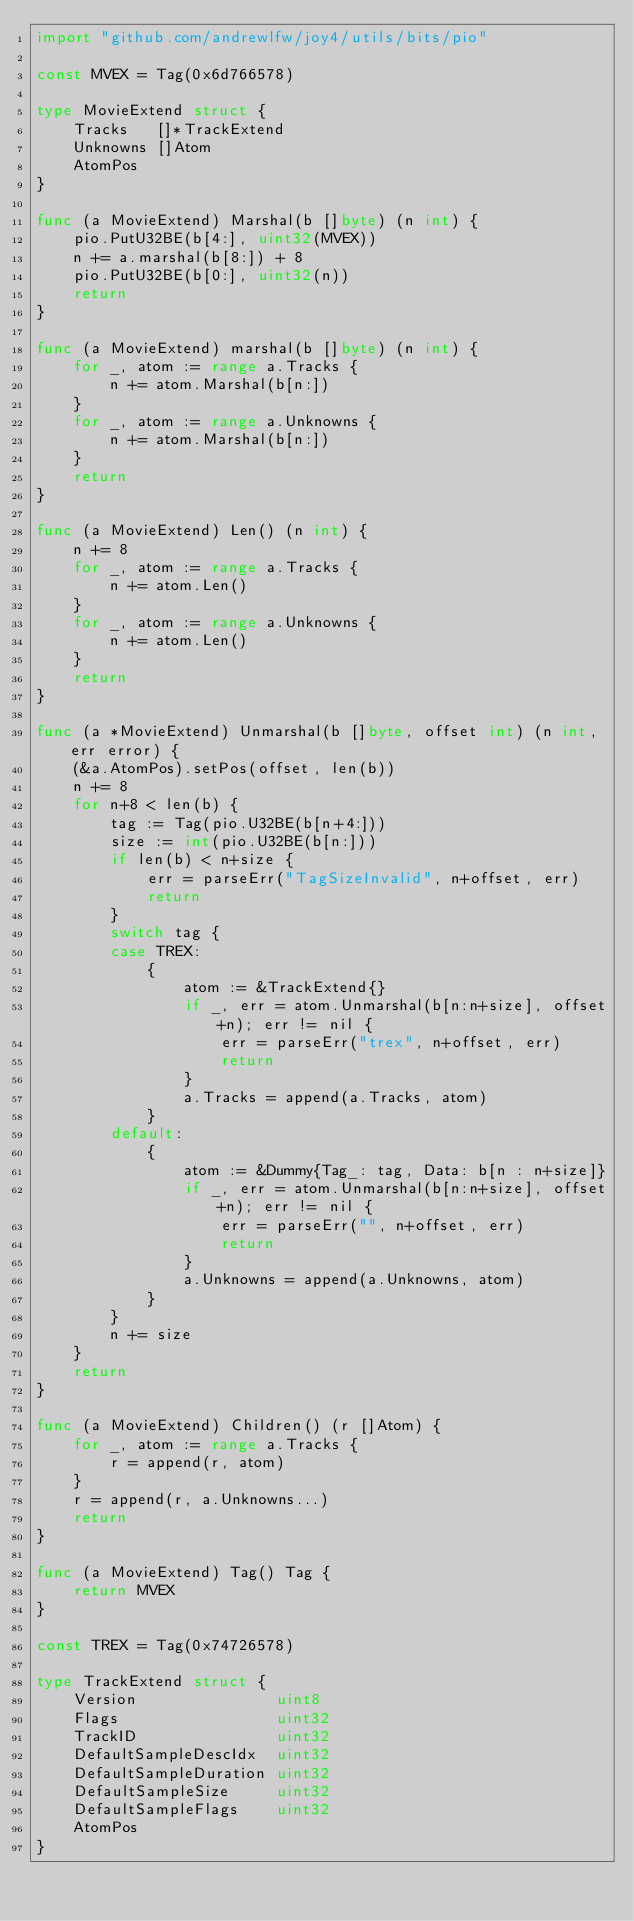Convert code to text. <code><loc_0><loc_0><loc_500><loc_500><_Go_>import "github.com/andrewlfw/joy4/utils/bits/pio"

const MVEX = Tag(0x6d766578)

type MovieExtend struct {
	Tracks   []*TrackExtend
	Unknowns []Atom
	AtomPos
}

func (a MovieExtend) Marshal(b []byte) (n int) {
	pio.PutU32BE(b[4:], uint32(MVEX))
	n += a.marshal(b[8:]) + 8
	pio.PutU32BE(b[0:], uint32(n))
	return
}

func (a MovieExtend) marshal(b []byte) (n int) {
	for _, atom := range a.Tracks {
		n += atom.Marshal(b[n:])
	}
	for _, atom := range a.Unknowns {
		n += atom.Marshal(b[n:])
	}
	return
}

func (a MovieExtend) Len() (n int) {
	n += 8
	for _, atom := range a.Tracks {
		n += atom.Len()
	}
	for _, atom := range a.Unknowns {
		n += atom.Len()
	}
	return
}

func (a *MovieExtend) Unmarshal(b []byte, offset int) (n int, err error) {
	(&a.AtomPos).setPos(offset, len(b))
	n += 8
	for n+8 < len(b) {
		tag := Tag(pio.U32BE(b[n+4:]))
		size := int(pio.U32BE(b[n:]))
		if len(b) < n+size {
			err = parseErr("TagSizeInvalid", n+offset, err)
			return
		}
		switch tag {
		case TREX:
			{
				atom := &TrackExtend{}
				if _, err = atom.Unmarshal(b[n:n+size], offset+n); err != nil {
					err = parseErr("trex", n+offset, err)
					return
				}
				a.Tracks = append(a.Tracks, atom)
			}
		default:
			{
				atom := &Dummy{Tag_: tag, Data: b[n : n+size]}
				if _, err = atom.Unmarshal(b[n:n+size], offset+n); err != nil {
					err = parseErr("", n+offset, err)
					return
				}
				a.Unknowns = append(a.Unknowns, atom)
			}
		}
		n += size
	}
	return
}

func (a MovieExtend) Children() (r []Atom) {
	for _, atom := range a.Tracks {
		r = append(r, atom)
	}
	r = append(r, a.Unknowns...)
	return
}

func (a MovieExtend) Tag() Tag {
	return MVEX
}

const TREX = Tag(0x74726578)

type TrackExtend struct {
	Version               uint8
	Flags                 uint32
	TrackID               uint32
	DefaultSampleDescIdx  uint32
	DefaultSampleDuration uint32
	DefaultSampleSize     uint32
	DefaultSampleFlags    uint32
	AtomPos
}
</code> 